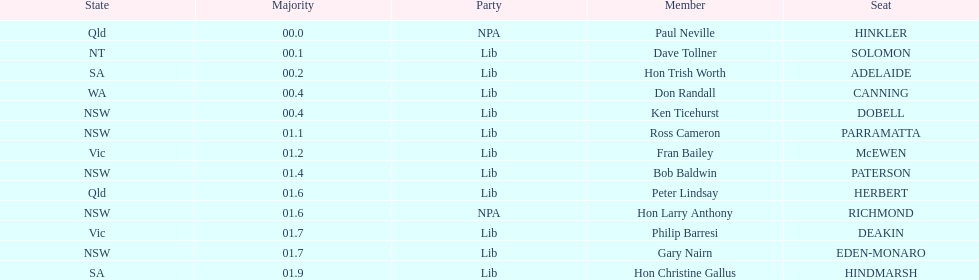How many states were represented in the seats? 6. 